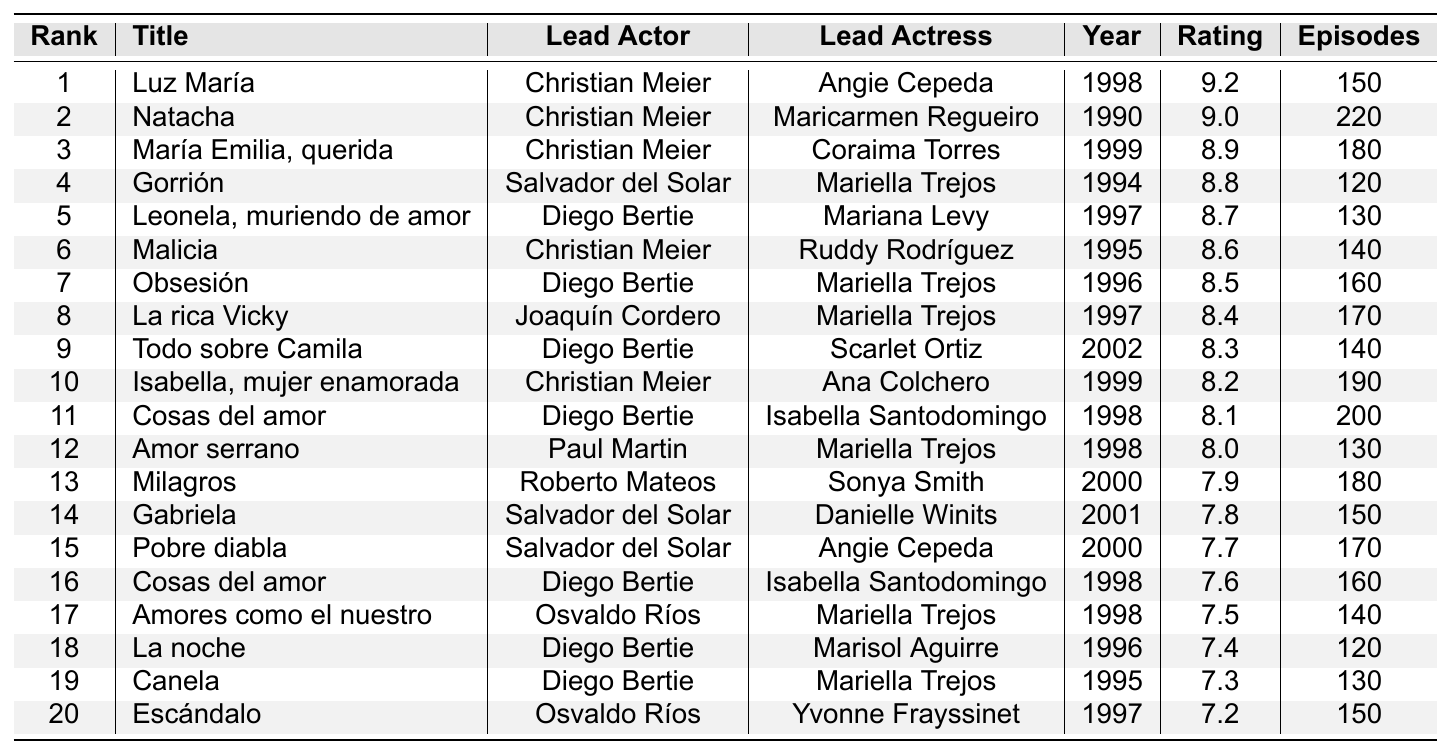What is the highest-rated telenovela on the list? The highest rating in the table is 9.2, associated with the telenovela "Luz María," which is found in the first rank.
Answer: Luz María Which telenovela has the most episodes? "Natacha" has the highest number of episodes at 220, which is shown in the total episodes column for rank 2.
Answer: Natacha How many telenovelas feature Mariella Trejos as the lead actress? By counting all the rows in the table where Mariella Trejos appears as the lead actress, we can find that she is listed in 5 telenovelas: "Gorrión," "Obsesión," "La rica Vicky," "Amor serrano," and "Amores como el nuestro."
Answer: 5 Who are the lead actors of the top 5 rated telenovelas? The lead actors for the top 5 rated telenovelas can be obtained by looking at the top 5 rows: Christian Meier (Luz María), Christian Meier (Natacha), Christian Meier (María Emilia, querida), Salvador del Solar (Gorrión), and Diego Bertie (Leonela, muriendo de amor).
Answer: Christian Meier, Salvador del Solar, Diego Bertie What is the average rating of telenovelas featuring Christian Meier as the lead actor? The ratings for Christian Meier's telenovelas are: 9.2 (Luz María), 9.0 (Natacha), 8.9 (María Emilia, querida), 8.6 (Malicia), and 8.2 (Isabella, mujer enamorada). Summing these gives 43.9. Since there are 5 telenovelas, the average rating = 43.9 / 5 = 8.78.
Answer: 8.78 Is there any telenovela that received a rating lower than 7.5? By checking the ratings provided in the table, we see "Escándalo" with a rating of 7.2, indicating it's less than 7.5.
Answer: Yes Which telenovela features the lead actress from "Canela"? The lead actress in "Canela" is Mariella Trejos. To find her other telenovelas, we refer to the table which shows she appears in "Gorrión," "Obsesión," "La rica Vicky," "Amor serrano," and "Amores como el nuestro."
Answer: Gorrión, Obsesión, La rica Vicky, Amor serrano, Amores como el nuestro What is the difference in average ratings between the telenovelas with the most and the least episodes? Telenovela with the most episodes is "Natacha" (220 episodes, 9.0 rating) and the one with the least episodes among the top 20 is "Gorrión" (120 episodes, 8.8 rating). The difference in ratings is 9.0 - 7.2 = 1.8.
Answer: 1.8 Which year was the majority of the telenovelas released? Looking at the years listed for the telenovelas, 1998 appears several times, especially for the top-rated shows. A count of the years shows that 1998 has the most occurrences when examining the data.
Answer: 1998 Can you find a telenovela with an average rating equal to 8.5? The table indicates that "Obsesión" has an average rating of 8.5, which matches the required condition directly seen in the ratings column.
Answer: Obsesión Who are the only lead actors to be in multiple telenovelas on the list? Observing the data, Diego Bertie appears in four different telenovelas, specifically: "Leonela, muriendo de amor," "Obsesión," "Todo sobre Camila," and "La noche." Similarly, Christian Meier appears in several telenovelas as well.
Answer: Diego Bertie, Christian Meier 